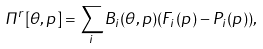Convert formula to latex. <formula><loc_0><loc_0><loc_500><loc_500>\Pi ^ { r } [ \theta , p ] = \sum _ { i } B _ { i } ( \theta , p ) ( F _ { i } ( p ) - P _ { i } ( p ) ) ,</formula> 